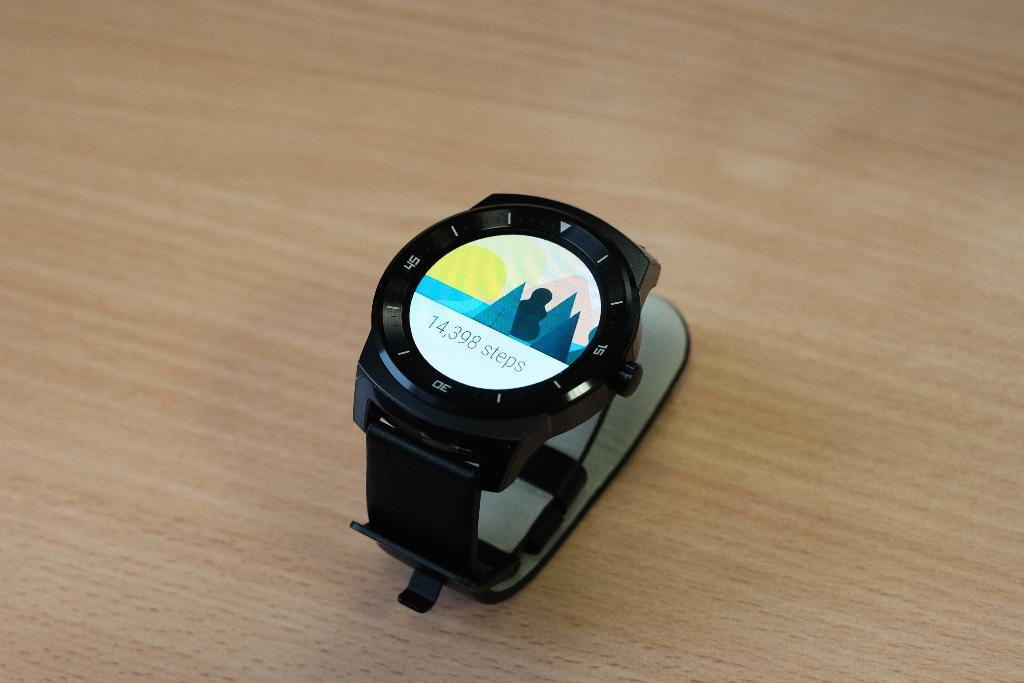Provide a one-sentence caption for the provided image. A watch that says 14,398 steps sits on top of a wooden surface. 